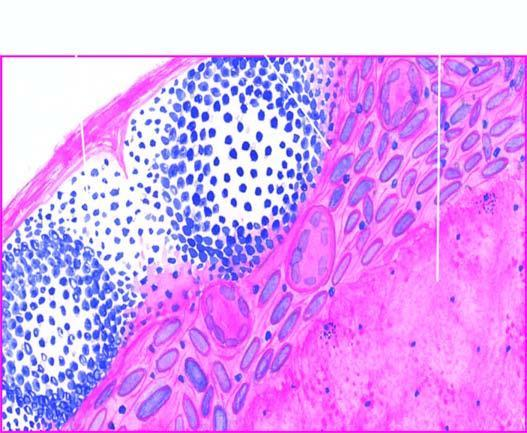what does the periphery show?
Answer the question using a single word or phrase. Granulomatous inflammation 